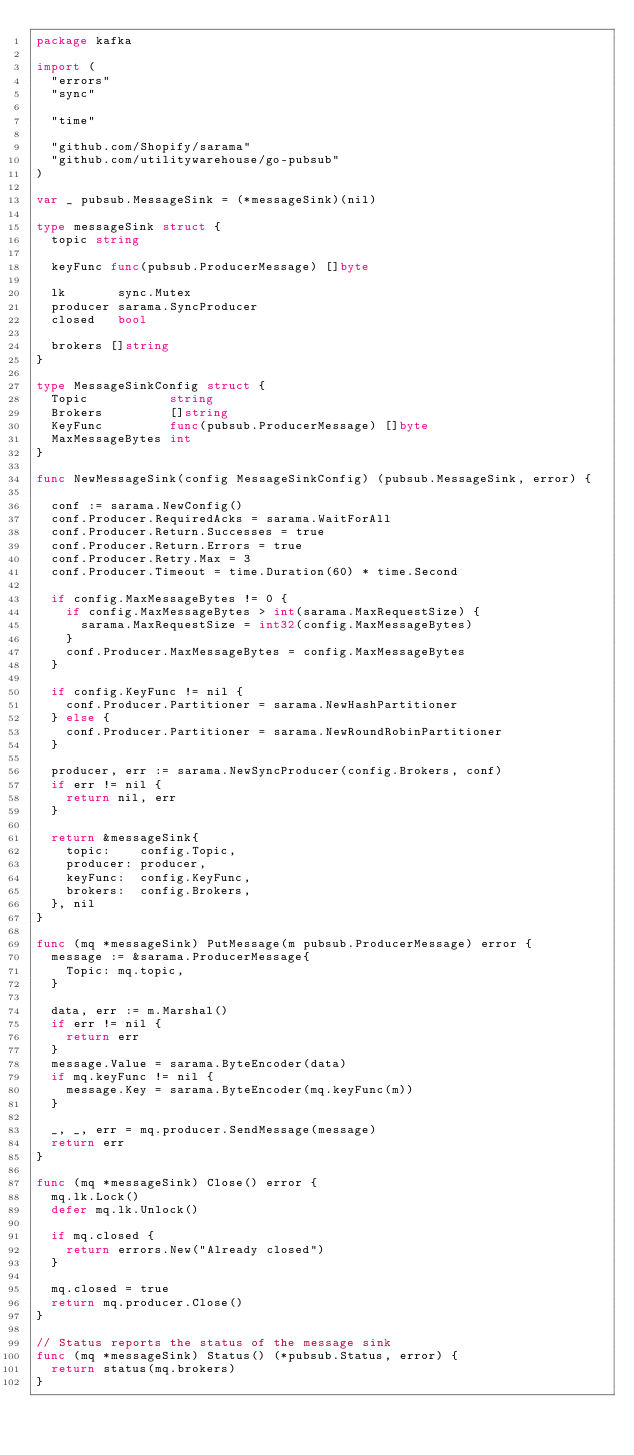Convert code to text. <code><loc_0><loc_0><loc_500><loc_500><_Go_>package kafka

import (
	"errors"
	"sync"

	"time"

	"github.com/Shopify/sarama"
	"github.com/utilitywarehouse/go-pubsub"
)

var _ pubsub.MessageSink = (*messageSink)(nil)

type messageSink struct {
	topic string

	keyFunc func(pubsub.ProducerMessage) []byte

	lk       sync.Mutex
	producer sarama.SyncProducer
	closed   bool

	brokers []string
}

type MessageSinkConfig struct {
	Topic           string
	Brokers         []string
	KeyFunc         func(pubsub.ProducerMessage) []byte
	MaxMessageBytes int
}

func NewMessageSink(config MessageSinkConfig) (pubsub.MessageSink, error) {

	conf := sarama.NewConfig()
	conf.Producer.RequiredAcks = sarama.WaitForAll
	conf.Producer.Return.Successes = true
	conf.Producer.Return.Errors = true
	conf.Producer.Retry.Max = 3
	conf.Producer.Timeout = time.Duration(60) * time.Second

	if config.MaxMessageBytes != 0 {
		if config.MaxMessageBytes > int(sarama.MaxRequestSize) {
			sarama.MaxRequestSize = int32(config.MaxMessageBytes)
		}
		conf.Producer.MaxMessageBytes = config.MaxMessageBytes
	}

	if config.KeyFunc != nil {
		conf.Producer.Partitioner = sarama.NewHashPartitioner
	} else {
		conf.Producer.Partitioner = sarama.NewRoundRobinPartitioner
	}

	producer, err := sarama.NewSyncProducer(config.Brokers, conf)
	if err != nil {
		return nil, err
	}

	return &messageSink{
		topic:    config.Topic,
		producer: producer,
		keyFunc:  config.KeyFunc,
		brokers:  config.Brokers,
	}, nil
}

func (mq *messageSink) PutMessage(m pubsub.ProducerMessage) error {
	message := &sarama.ProducerMessage{
		Topic: mq.topic,
	}

	data, err := m.Marshal()
	if err != nil {
		return err
	}
	message.Value = sarama.ByteEncoder(data)
	if mq.keyFunc != nil {
		message.Key = sarama.ByteEncoder(mq.keyFunc(m))
	}

	_, _, err = mq.producer.SendMessage(message)
	return err
}

func (mq *messageSink) Close() error {
	mq.lk.Lock()
	defer mq.lk.Unlock()

	if mq.closed {
		return errors.New("Already closed")
	}

	mq.closed = true
	return mq.producer.Close()
}

// Status reports the status of the message sink
func (mq *messageSink) Status() (*pubsub.Status, error) {
	return status(mq.brokers)
}
</code> 